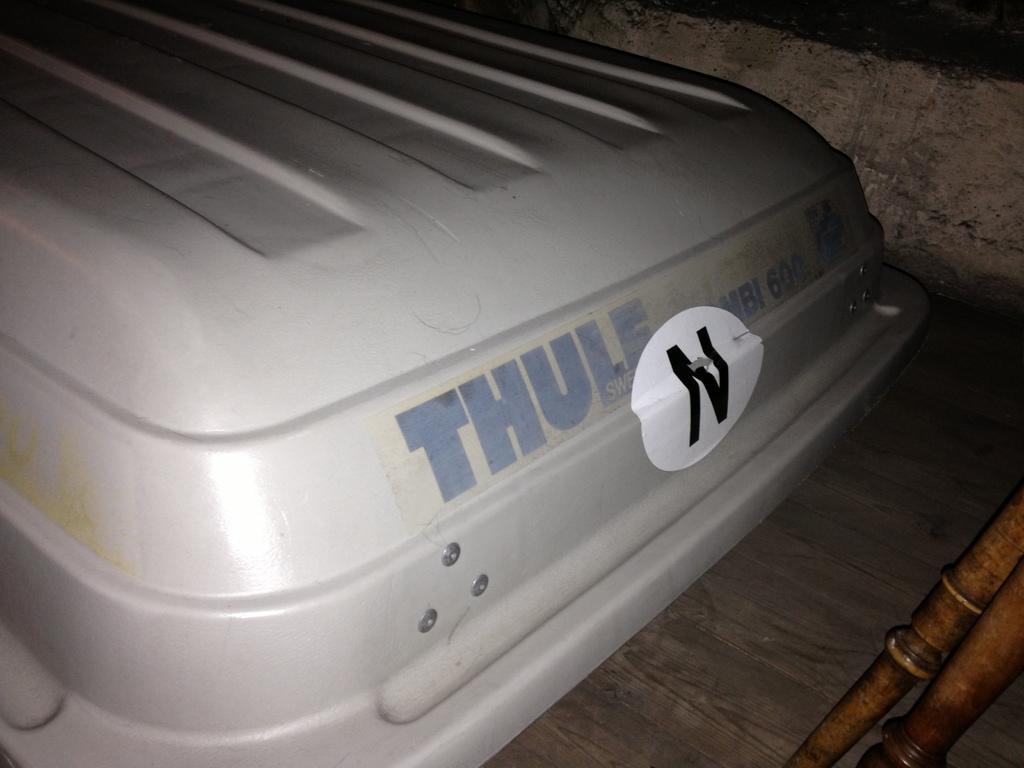Can you describe this image briefly? At the bottom right side of the image we can see some wooden objects. In the center of the image, we can see one vehicle. On the vehicle, we can see some text. In the background there is a wall and a few other objects. 